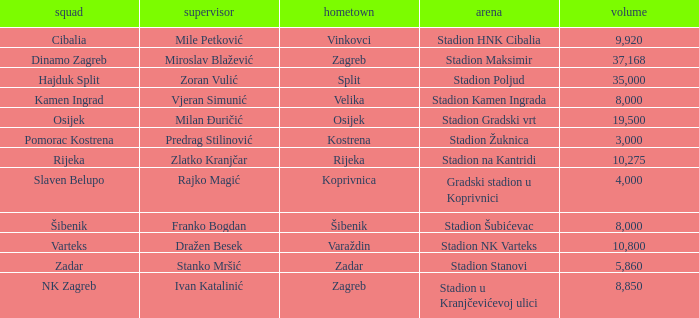What is the stadium of the NK Zagreb? Stadion u Kranjčevićevoj ulici. Can you give me this table as a dict? {'header': ['squad', 'supervisor', 'hometown', 'arena', 'volume'], 'rows': [['Cibalia', 'Mile Petković', 'Vinkovci', 'Stadion HNK Cibalia', '9,920'], ['Dinamo Zagreb', 'Miroslav Blažević', 'Zagreb', 'Stadion Maksimir', '37,168'], ['Hajduk Split', 'Zoran Vulić', 'Split', 'Stadion Poljud', '35,000'], ['Kamen Ingrad', 'Vjeran Simunić', 'Velika', 'Stadion Kamen Ingrada', '8,000'], ['Osijek', 'Milan Đuričić', 'Osijek', 'Stadion Gradski vrt', '19,500'], ['Pomorac Kostrena', 'Predrag Stilinović', 'Kostrena', 'Stadion Žuknica', '3,000'], ['Rijeka', 'Zlatko Kranjčar', 'Rijeka', 'Stadion na Kantridi', '10,275'], ['Slaven Belupo', 'Rajko Magić', 'Koprivnica', 'Gradski stadion u Koprivnici', '4,000'], ['Šibenik', 'Franko Bogdan', 'Šibenik', 'Stadion Šubićevac', '8,000'], ['Varteks', 'Dražen Besek', 'Varaždin', 'Stadion NK Varteks', '10,800'], ['Zadar', 'Stanko Mršić', 'Zadar', 'Stadion Stanovi', '5,860'], ['NK Zagreb', 'Ivan Katalinić', 'Zagreb', 'Stadion u Kranjčevićevoj ulici', '8,850']]} 